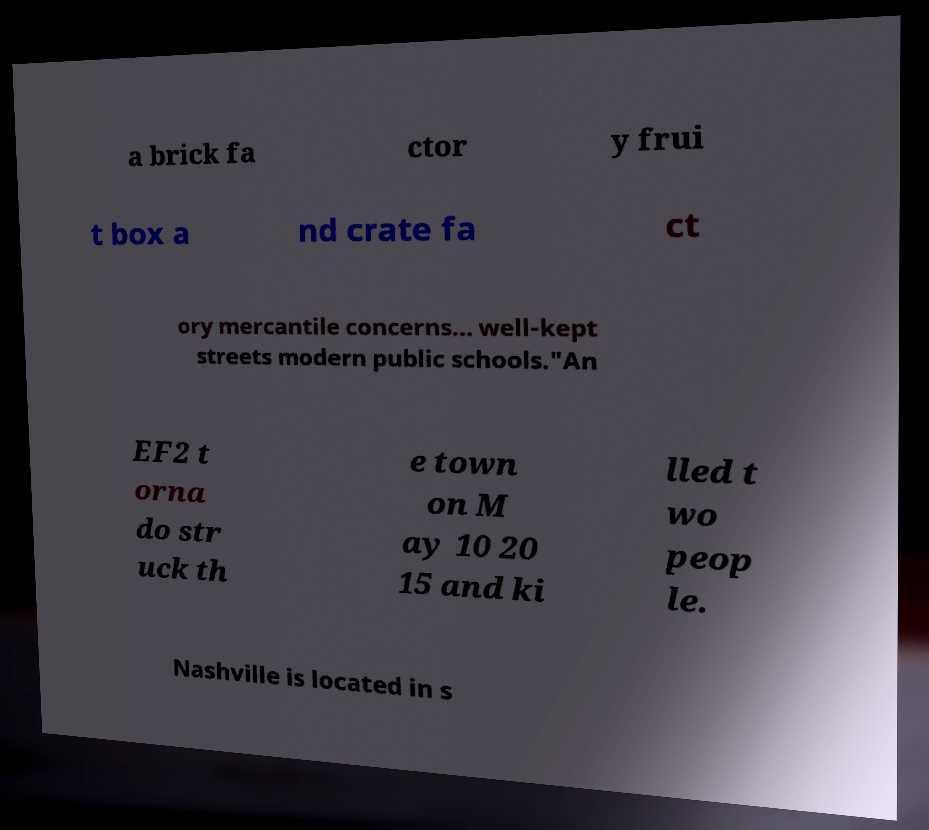What messages or text are displayed in this image? I need them in a readable, typed format. a brick fa ctor y frui t box a nd crate fa ct ory mercantile concerns... well-kept streets modern public schools."An EF2 t orna do str uck th e town on M ay 10 20 15 and ki lled t wo peop le. Nashville is located in s 